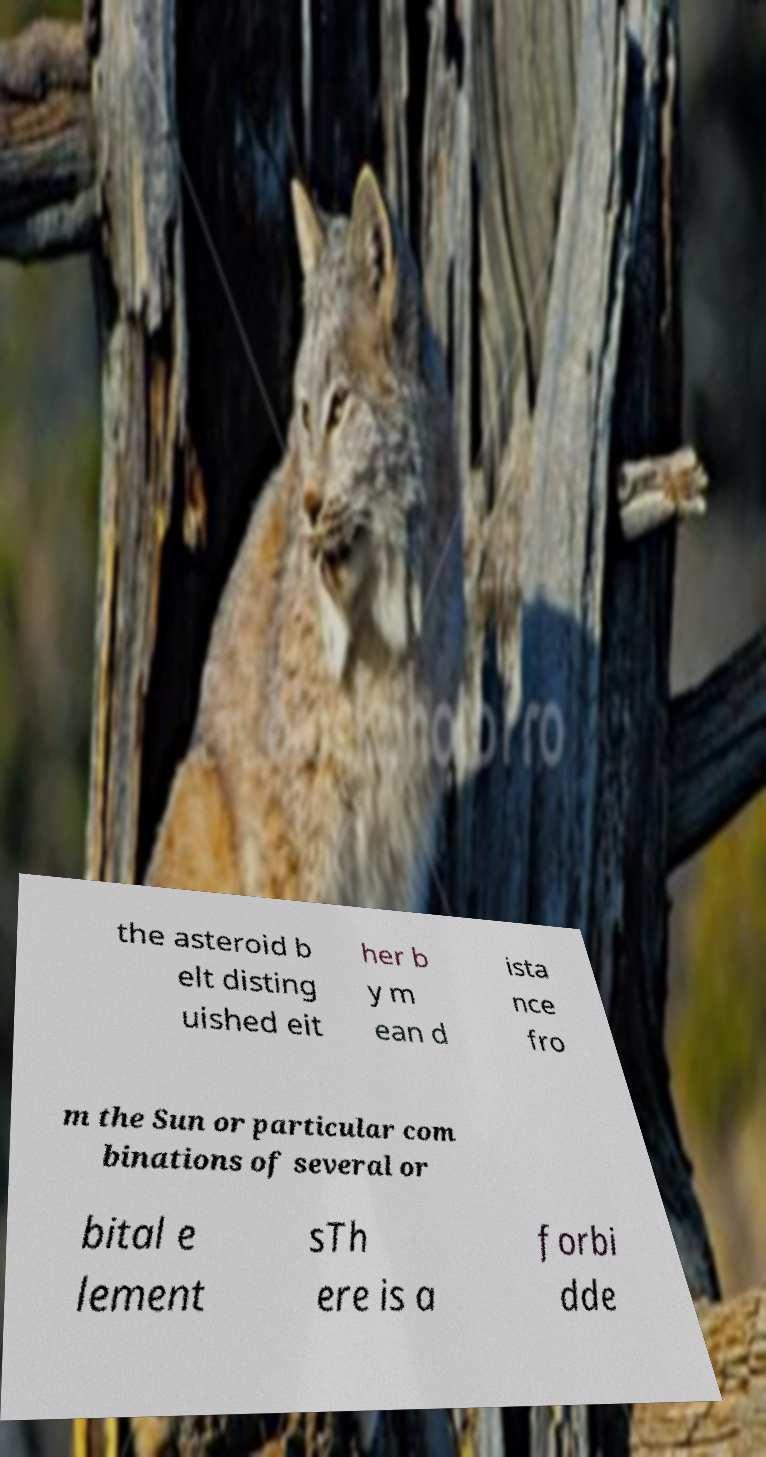What messages or text are displayed in this image? I need them in a readable, typed format. the asteroid b elt disting uished eit her b y m ean d ista nce fro m the Sun or particular com binations of several or bital e lement sTh ere is a forbi dde 